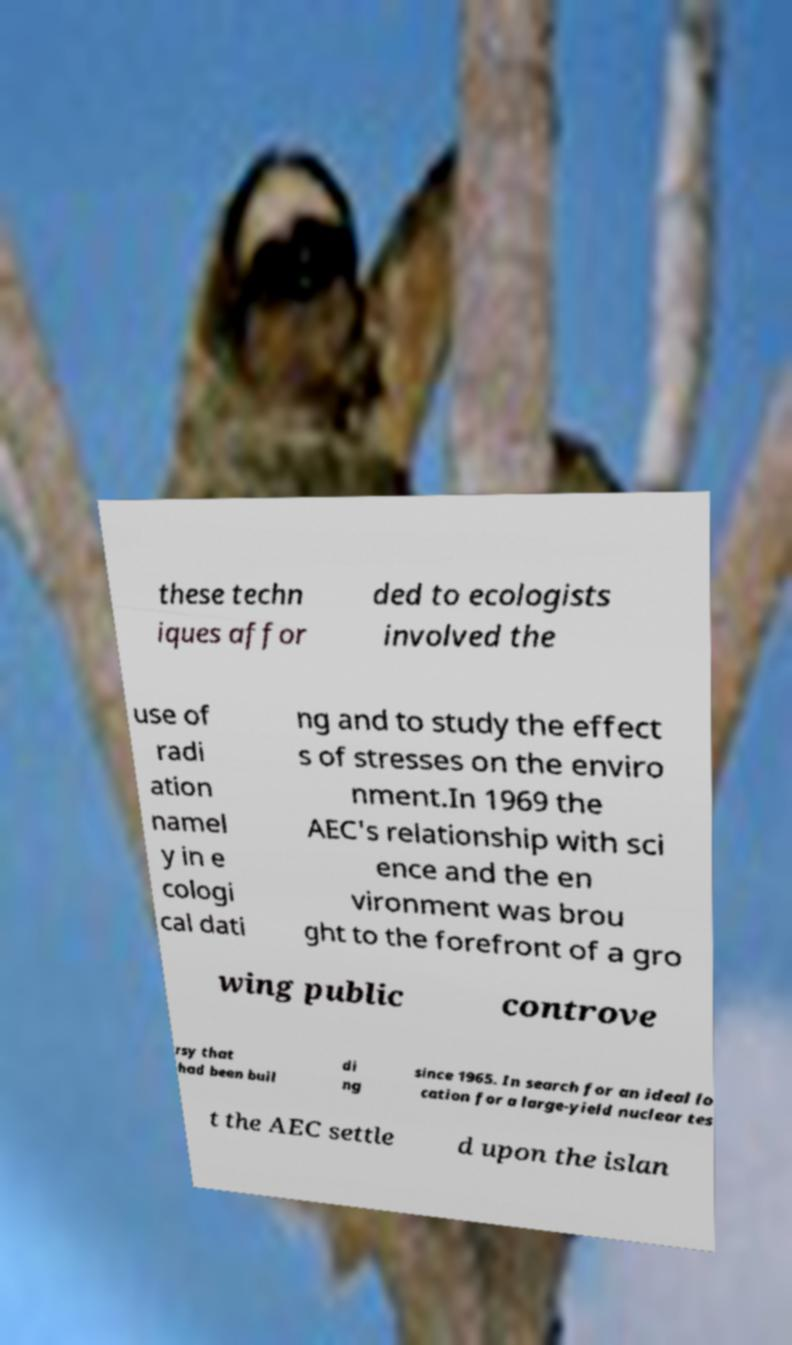Could you extract and type out the text from this image? these techn iques affor ded to ecologists involved the use of radi ation namel y in e cologi cal dati ng and to study the effect s of stresses on the enviro nment.In 1969 the AEC's relationship with sci ence and the en vironment was brou ght to the forefront of a gro wing public controve rsy that had been buil di ng since 1965. In search for an ideal lo cation for a large-yield nuclear tes t the AEC settle d upon the islan 